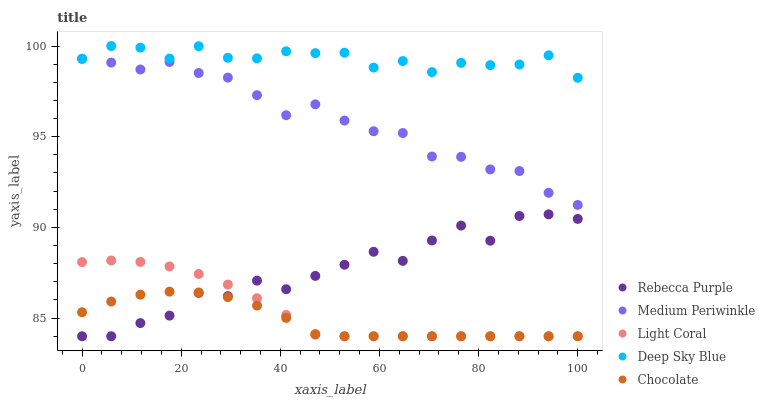Does Chocolate have the minimum area under the curve?
Answer yes or no. Yes. Does Deep Sky Blue have the maximum area under the curve?
Answer yes or no. Yes. Does Medium Periwinkle have the minimum area under the curve?
Answer yes or no. No. Does Medium Periwinkle have the maximum area under the curve?
Answer yes or no. No. Is Light Coral the smoothest?
Answer yes or no. Yes. Is Rebecca Purple the roughest?
Answer yes or no. Yes. Is Medium Periwinkle the smoothest?
Answer yes or no. No. Is Medium Periwinkle the roughest?
Answer yes or no. No. Does Light Coral have the lowest value?
Answer yes or no. Yes. Does Medium Periwinkle have the lowest value?
Answer yes or no. No. Does Deep Sky Blue have the highest value?
Answer yes or no. Yes. Does Medium Periwinkle have the highest value?
Answer yes or no. No. Is Chocolate less than Medium Periwinkle?
Answer yes or no. Yes. Is Deep Sky Blue greater than Rebecca Purple?
Answer yes or no. Yes. Does Light Coral intersect Chocolate?
Answer yes or no. Yes. Is Light Coral less than Chocolate?
Answer yes or no. No. Is Light Coral greater than Chocolate?
Answer yes or no. No. Does Chocolate intersect Medium Periwinkle?
Answer yes or no. No. 